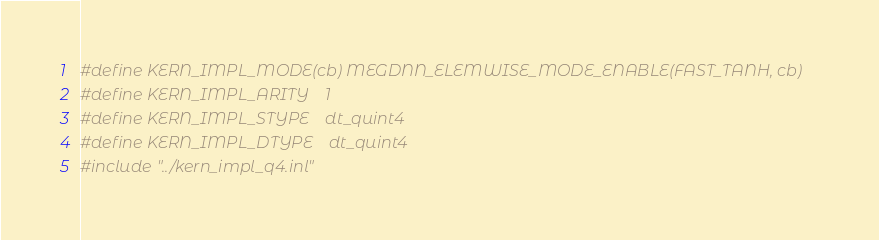Convert code to text. <code><loc_0><loc_0><loc_500><loc_500><_Cuda_>#define KERN_IMPL_MODE(cb) MEGDNN_ELEMWISE_MODE_ENABLE(FAST_TANH, cb)
#define KERN_IMPL_ARITY    1
#define KERN_IMPL_STYPE    dt_quint4
#define KERN_IMPL_DTYPE    dt_quint4
#include "../kern_impl_q4.inl"
</code> 